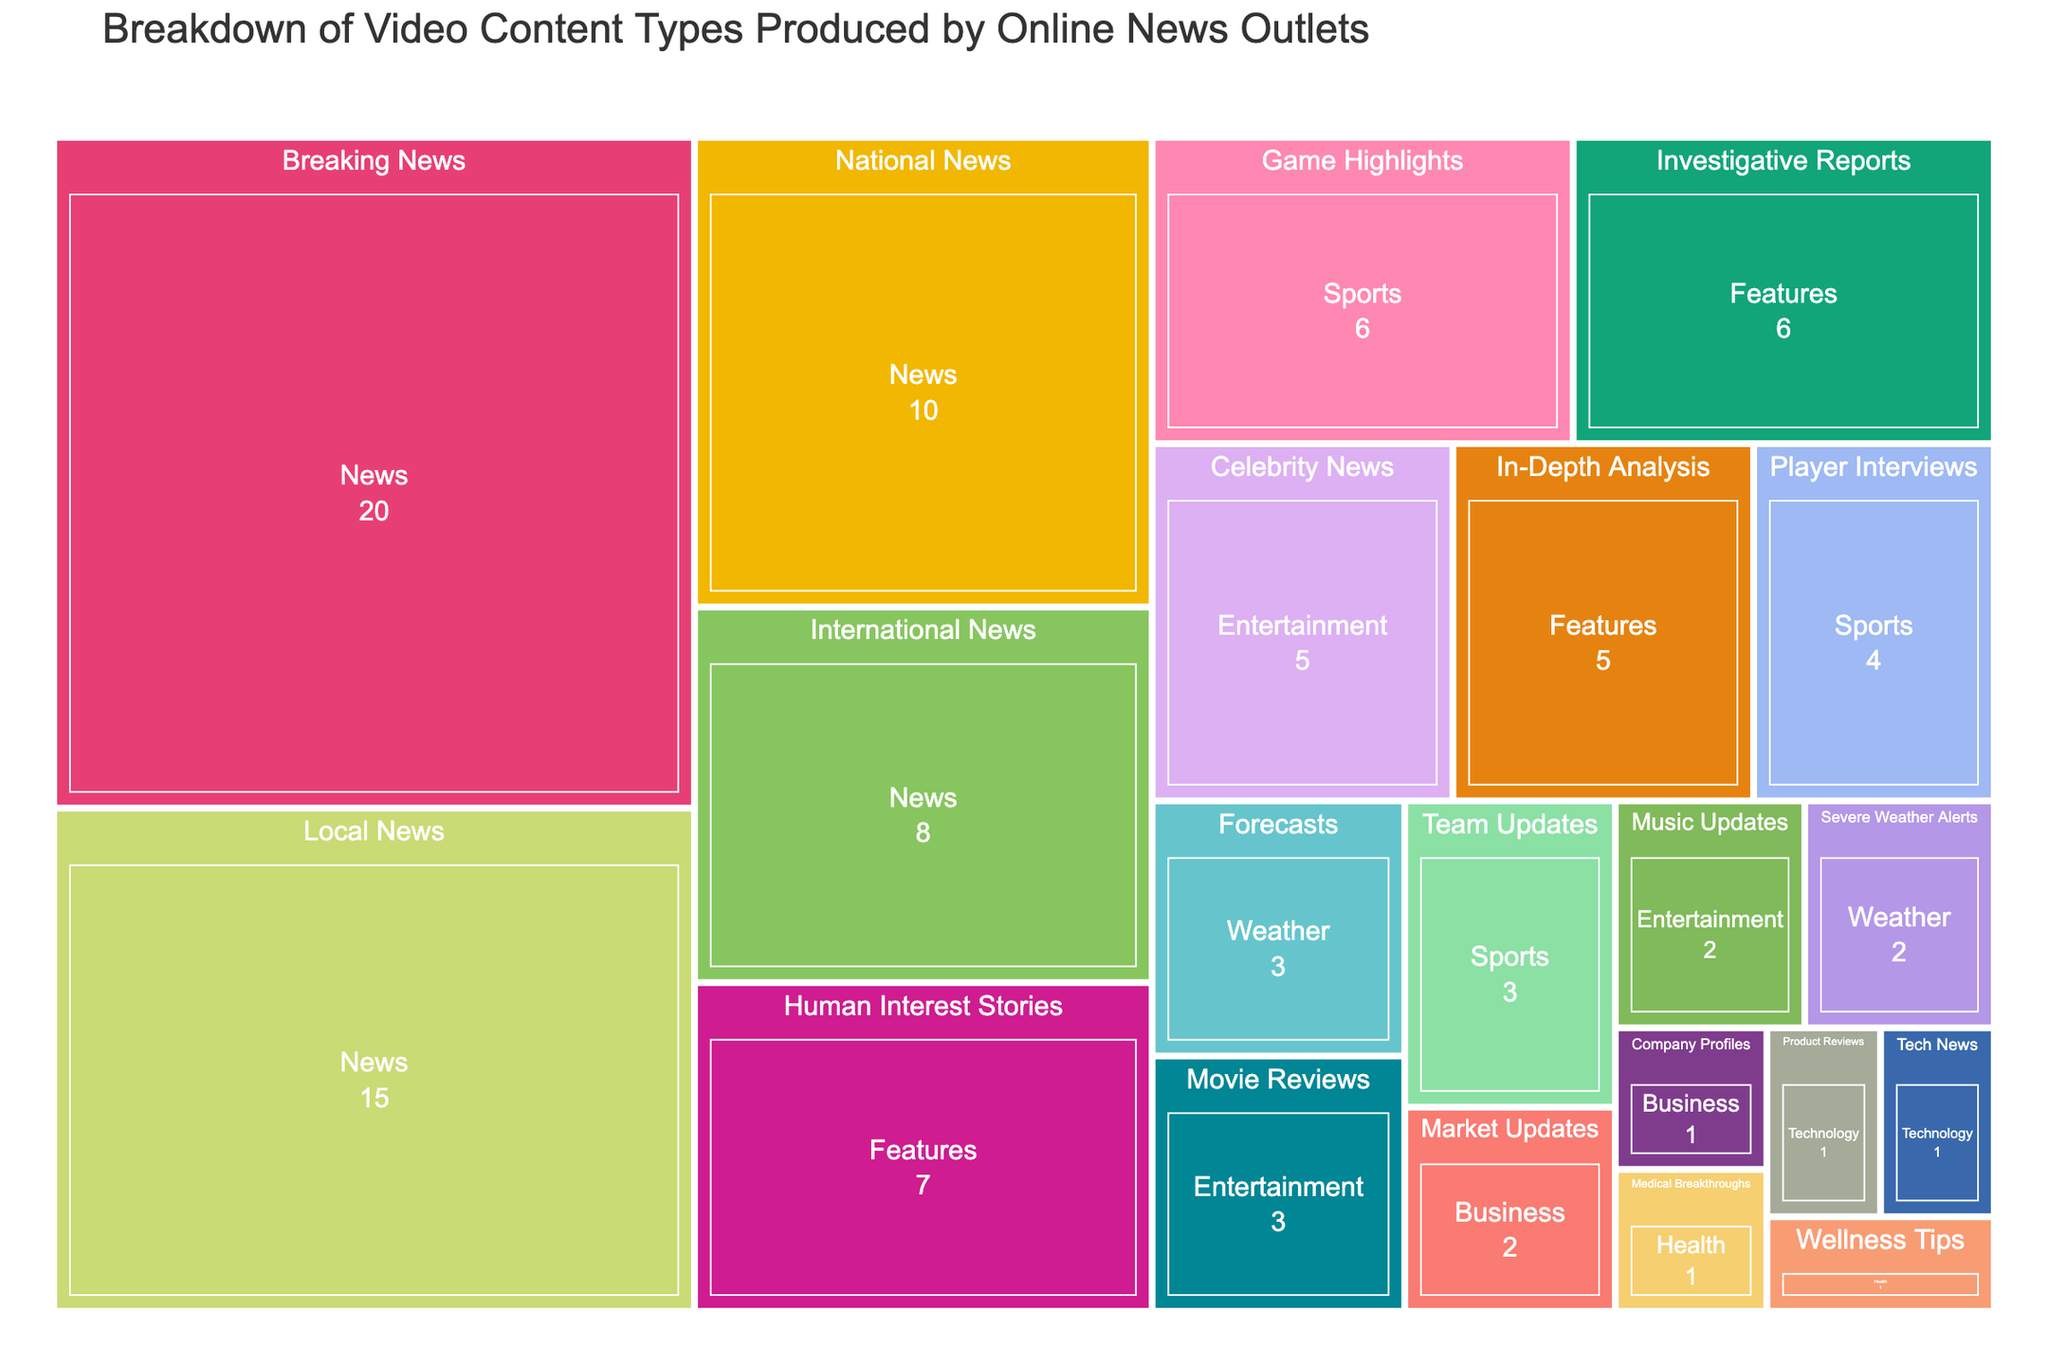what's the largest category in terms of percentage? The figure shows the breakdown of various video content types with their percentages. By examining the sizes, we see that "Breaking News" under the "News" category occupies the largest portion with 20%.
Answer: News (Breaking News) what are the combined percentages of "Music Updates" and "Movie Reviews"? "Music Updates" has a percentage of 2% and "Movie Reviews" has a percentage of 3%. Adding them together gives 5%.
Answer: 5% Which content type under "Sports" has the smallest percentage? There are three content types under "Sports": "Game Highlights," "Player Interviews," and "Team Updates." "Team Updates" has the smallest percentage with 3%.
Answer: Team Updates How does the percentage of "Human Interest Stories" compare to "Investigative Reports"? "Human Interest Stories" has a percentage of 7%, whereas "Investigative Reports" has 6%. Therefore, "Human Interest Stories" occupies a larger portion than "Investigative Reports".
Answer: Human Interest Stories > Investigative Reports What's the total percentage for the "Weather" category? The "Weather" category has two content types: "Forecasts" with 3% and "Severe Weather Alerts" with 2%. Adding these together, we get a total of 5%.
Answer: 5% Which category has the highest number of content types, and how many does it have? By looking at the figure, the "News" category has the highest number of content types. There are four: "Breaking News," "Local News," "National News," and "International News."
Answer: News, 4 content types Is the percentage of "Forecasts" equal to "Team Updates"? Both "Forecasts" and "Team Updates" have a percentage value of 3%. Therefore, their percentages are equal.
Answer: Yes If we combine "Market Updates" and "Company Profiles," do they exceed the percentage of "Player Interviews"? "Market Updates" has 2% and "Company Profiles" has 1%. Combined, they sum up to 3%, which is equal to the percentage for "Player Interviews." Therefore, they do not exceed "Player Interviews."
Answer: No Rank the categories "Business," "Health," and "Technology" by their total percentages. "Business" has 2% ("Market Updates") + 1% ("Company Profiles") = 3%. "Health" has 1% ("Medical Breakthroughs") + 1% ("Wellness Tips") = 2%. "Technology" has 1% ("Product Reviews") + 1% ("Tech News") = 2%. Thus, Business > Health = Technology.
Answer: Business > Health = Technology Which two content types together make up 10% and belong to the same category? "National News" (10%) from the "News" category. No other pair sums to 10%. " player_interviews " has 4% in "sports" category.
Answer: National News 